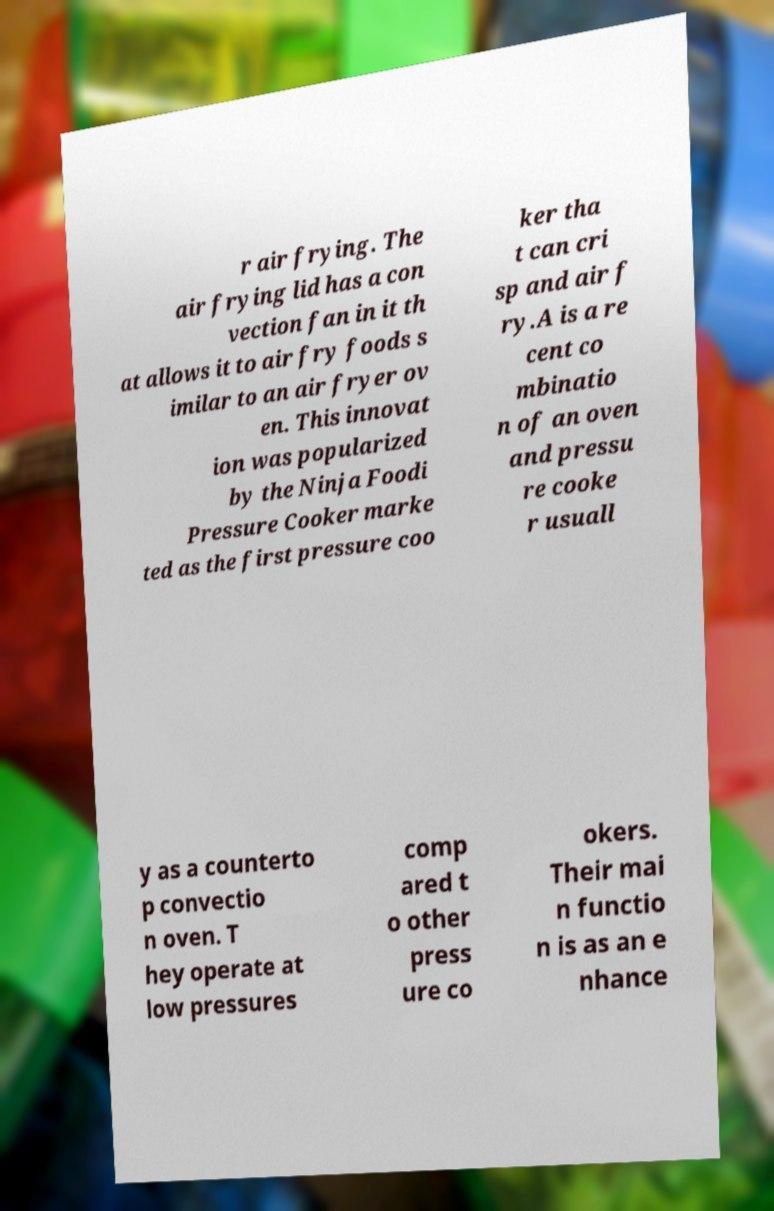Could you extract and type out the text from this image? r air frying. The air frying lid has a con vection fan in it th at allows it to air fry foods s imilar to an air fryer ov en. This innovat ion was popularized by the Ninja Foodi Pressure Cooker marke ted as the first pressure coo ker tha t can cri sp and air f ry.A is a re cent co mbinatio n of an oven and pressu re cooke r usuall y as a counterto p convectio n oven. T hey operate at low pressures comp ared t o other press ure co okers. Their mai n functio n is as an e nhance 